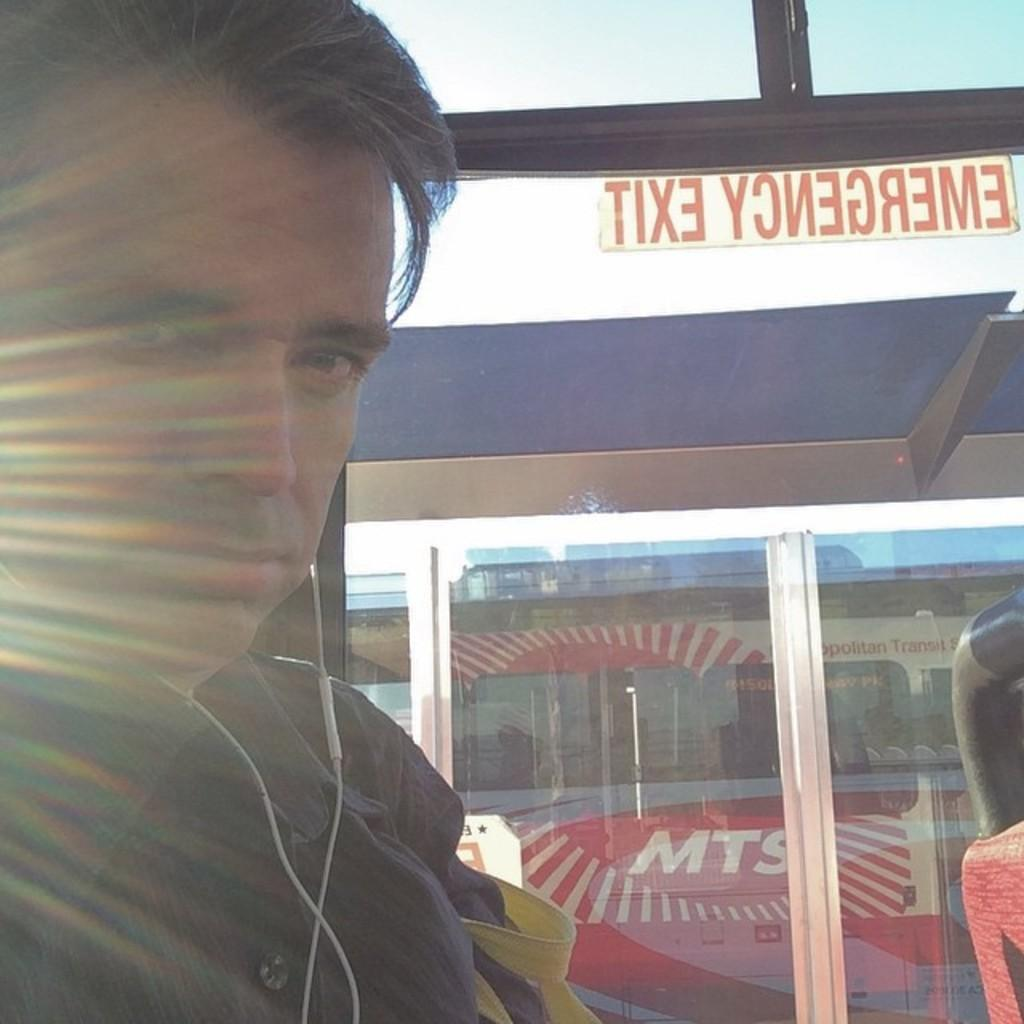Who or what is present in the image? There is a person in the image. Can you describe the person's attire? The person is wearing clothes. What architectural feature can be seen at the bottom of the image? There is a window at the bottom of the image. Where is the sticker located in the image? The sticker is in the top right of the image. What type of house is the person trying to attract the attention of in the image? There is no house present in the image, and the person is not trying to attract anyone's attention. Can you describe the toad that is sitting on the person's shoulder in the image? There is no toad present in the image. 